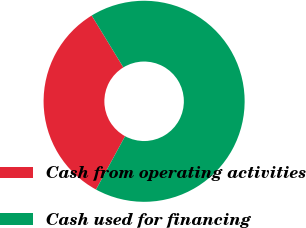Convert chart to OTSL. <chart><loc_0><loc_0><loc_500><loc_500><pie_chart><fcel>Cash from operating activities<fcel>Cash used for financing<nl><fcel>33.33%<fcel>66.67%<nl></chart> 